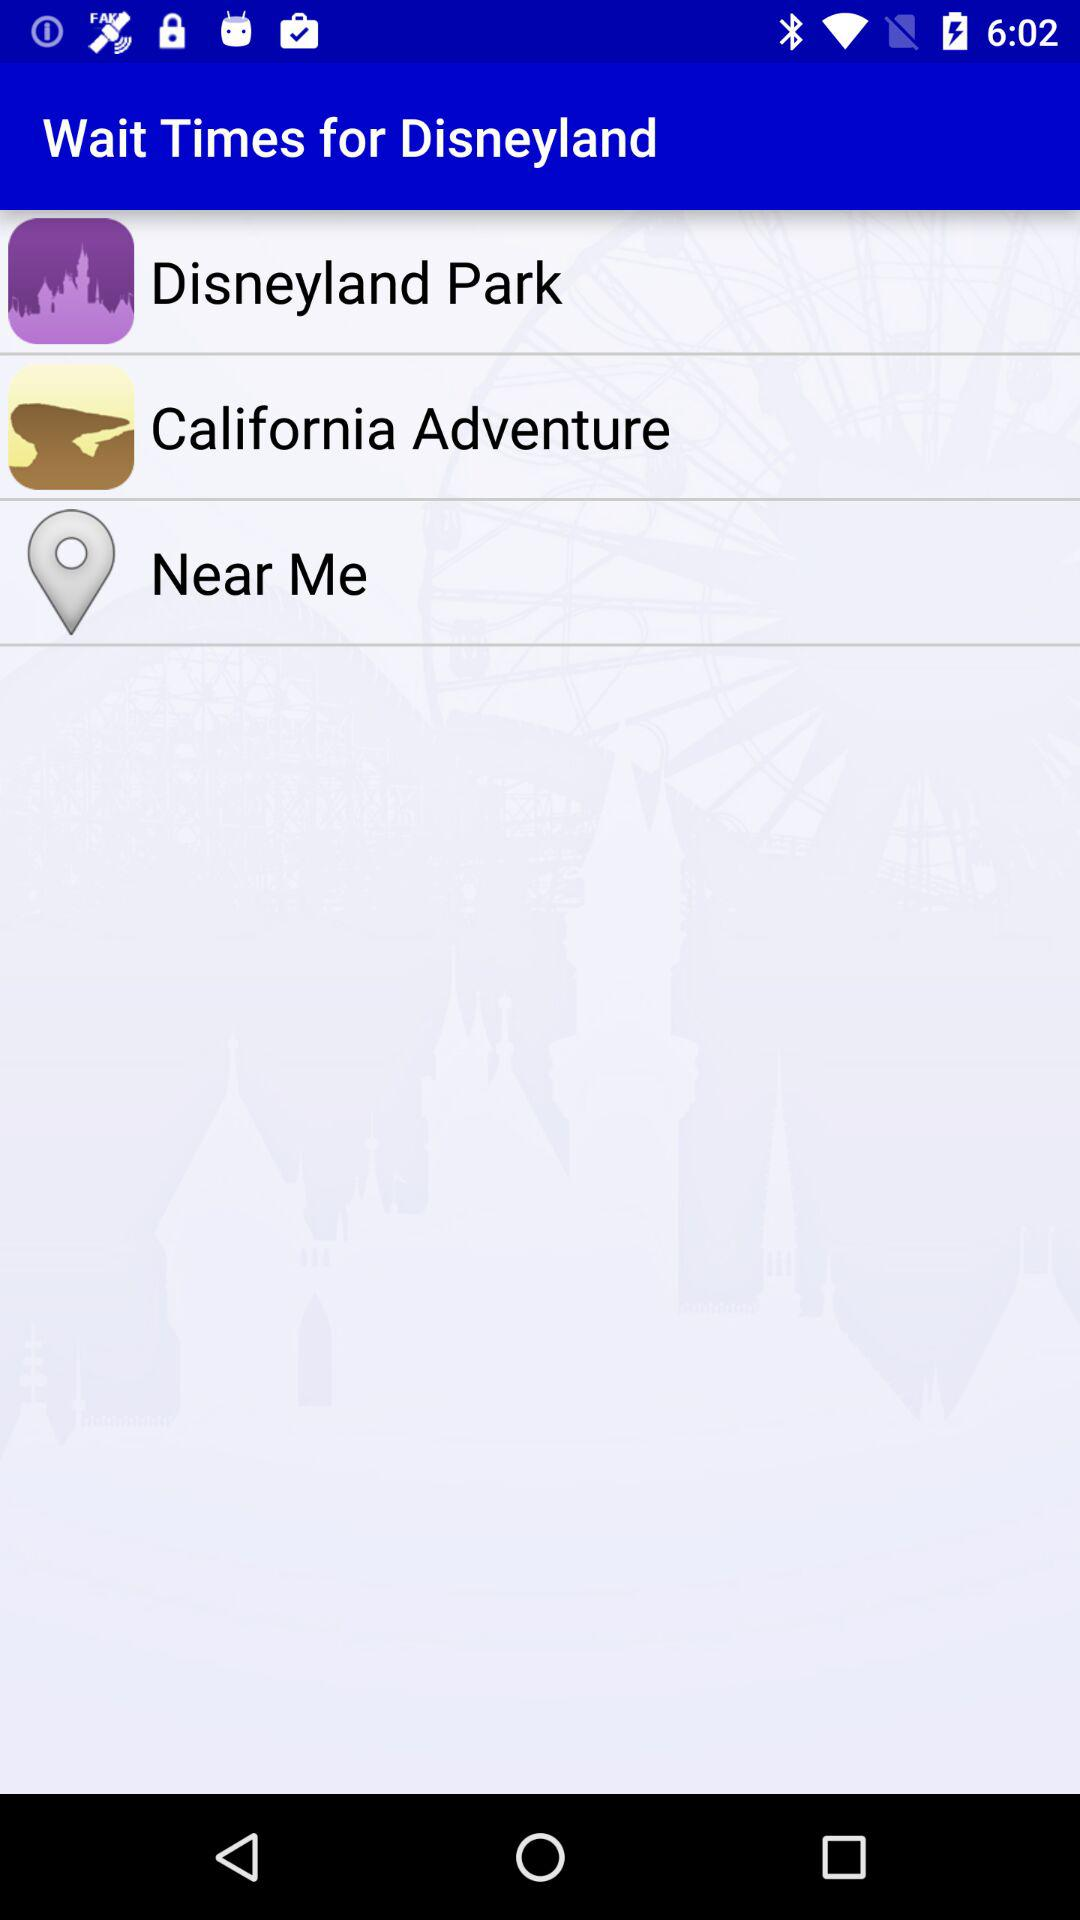What is the name of the application? The name of the application is "Wait Times for Disneyland". 